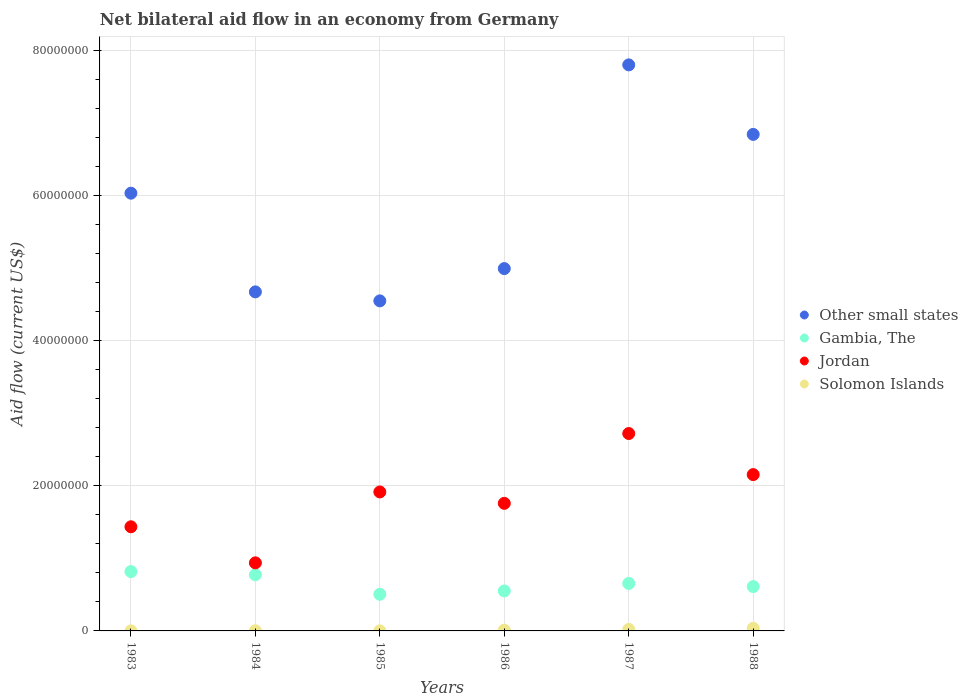How many different coloured dotlines are there?
Ensure brevity in your answer.  4. Is the number of dotlines equal to the number of legend labels?
Your answer should be compact. Yes. What is the net bilateral aid flow in Gambia, The in 1986?
Offer a terse response. 5.51e+06. Across all years, what is the maximum net bilateral aid flow in Jordan?
Give a very brief answer. 2.72e+07. In which year was the net bilateral aid flow in Other small states maximum?
Offer a very short reply. 1987. In which year was the net bilateral aid flow in Gambia, The minimum?
Provide a succinct answer. 1985. What is the total net bilateral aid flow in Solomon Islands in the graph?
Your answer should be compact. 7.20e+05. What is the difference between the net bilateral aid flow in Other small states in 1984 and that in 1988?
Keep it short and to the point. -2.17e+07. What is the difference between the net bilateral aid flow in Solomon Islands in 1985 and the net bilateral aid flow in Gambia, The in 1986?
Give a very brief answer. -5.50e+06. What is the average net bilateral aid flow in Jordan per year?
Give a very brief answer. 1.82e+07. In the year 1986, what is the difference between the net bilateral aid flow in Solomon Islands and net bilateral aid flow in Other small states?
Your answer should be very brief. -4.98e+07. In how many years, is the net bilateral aid flow in Gambia, The greater than 72000000 US$?
Offer a very short reply. 0. What is the ratio of the net bilateral aid flow in Gambia, The in 1985 to that in 1987?
Your answer should be very brief. 0.77. What is the difference between the highest and the lowest net bilateral aid flow in Solomon Islands?
Your response must be concise. 3.50e+05. Is it the case that in every year, the sum of the net bilateral aid flow in Jordan and net bilateral aid flow in Gambia, The  is greater than the net bilateral aid flow in Other small states?
Provide a short and direct response. No. Does the net bilateral aid flow in Other small states monotonically increase over the years?
Offer a terse response. No. Is the net bilateral aid flow in Gambia, The strictly greater than the net bilateral aid flow in Solomon Islands over the years?
Ensure brevity in your answer.  Yes. Is the net bilateral aid flow in Jordan strictly less than the net bilateral aid flow in Solomon Islands over the years?
Your answer should be very brief. No. Does the graph contain any zero values?
Your response must be concise. No. Where does the legend appear in the graph?
Your answer should be compact. Center right. What is the title of the graph?
Keep it short and to the point. Net bilateral aid flow in an economy from Germany. What is the label or title of the X-axis?
Keep it short and to the point. Years. What is the label or title of the Y-axis?
Provide a succinct answer. Aid flow (current US$). What is the Aid flow (current US$) of Other small states in 1983?
Offer a terse response. 6.03e+07. What is the Aid flow (current US$) in Gambia, The in 1983?
Offer a terse response. 8.18e+06. What is the Aid flow (current US$) in Jordan in 1983?
Provide a succinct answer. 1.44e+07. What is the Aid flow (current US$) of Other small states in 1984?
Ensure brevity in your answer.  4.67e+07. What is the Aid flow (current US$) in Gambia, The in 1984?
Ensure brevity in your answer.  7.74e+06. What is the Aid flow (current US$) of Jordan in 1984?
Your answer should be very brief. 9.38e+06. What is the Aid flow (current US$) in Other small states in 1985?
Ensure brevity in your answer.  4.55e+07. What is the Aid flow (current US$) in Gambia, The in 1985?
Your answer should be compact. 5.05e+06. What is the Aid flow (current US$) of Jordan in 1985?
Keep it short and to the point. 1.92e+07. What is the Aid flow (current US$) in Other small states in 1986?
Your answer should be compact. 4.99e+07. What is the Aid flow (current US$) in Gambia, The in 1986?
Provide a short and direct response. 5.51e+06. What is the Aid flow (current US$) in Jordan in 1986?
Ensure brevity in your answer.  1.76e+07. What is the Aid flow (current US$) in Solomon Islands in 1986?
Offer a very short reply. 1.10e+05. What is the Aid flow (current US$) in Other small states in 1987?
Provide a short and direct response. 7.80e+07. What is the Aid flow (current US$) of Gambia, The in 1987?
Give a very brief answer. 6.54e+06. What is the Aid flow (current US$) of Jordan in 1987?
Keep it short and to the point. 2.72e+07. What is the Aid flow (current US$) in Other small states in 1988?
Offer a very short reply. 6.84e+07. What is the Aid flow (current US$) in Gambia, The in 1988?
Keep it short and to the point. 6.11e+06. What is the Aid flow (current US$) in Jordan in 1988?
Ensure brevity in your answer.  2.15e+07. Across all years, what is the maximum Aid flow (current US$) in Other small states?
Your answer should be very brief. 7.80e+07. Across all years, what is the maximum Aid flow (current US$) of Gambia, The?
Provide a succinct answer. 8.18e+06. Across all years, what is the maximum Aid flow (current US$) in Jordan?
Provide a succinct answer. 2.72e+07. Across all years, what is the minimum Aid flow (current US$) in Other small states?
Give a very brief answer. 4.55e+07. Across all years, what is the minimum Aid flow (current US$) of Gambia, The?
Make the answer very short. 5.05e+06. Across all years, what is the minimum Aid flow (current US$) in Jordan?
Provide a short and direct response. 9.38e+06. What is the total Aid flow (current US$) in Other small states in the graph?
Your answer should be very brief. 3.49e+08. What is the total Aid flow (current US$) of Gambia, The in the graph?
Offer a very short reply. 3.91e+07. What is the total Aid flow (current US$) in Jordan in the graph?
Provide a short and direct response. 1.09e+08. What is the total Aid flow (current US$) in Solomon Islands in the graph?
Your response must be concise. 7.20e+05. What is the difference between the Aid flow (current US$) of Other small states in 1983 and that in 1984?
Offer a very short reply. 1.36e+07. What is the difference between the Aid flow (current US$) in Jordan in 1983 and that in 1984?
Your response must be concise. 4.97e+06. What is the difference between the Aid flow (current US$) of Other small states in 1983 and that in 1985?
Keep it short and to the point. 1.48e+07. What is the difference between the Aid flow (current US$) of Gambia, The in 1983 and that in 1985?
Ensure brevity in your answer.  3.13e+06. What is the difference between the Aid flow (current US$) of Jordan in 1983 and that in 1985?
Offer a very short reply. -4.80e+06. What is the difference between the Aid flow (current US$) of Solomon Islands in 1983 and that in 1985?
Ensure brevity in your answer.  0. What is the difference between the Aid flow (current US$) of Other small states in 1983 and that in 1986?
Keep it short and to the point. 1.04e+07. What is the difference between the Aid flow (current US$) in Gambia, The in 1983 and that in 1986?
Your answer should be very brief. 2.67e+06. What is the difference between the Aid flow (current US$) of Jordan in 1983 and that in 1986?
Give a very brief answer. -3.23e+06. What is the difference between the Aid flow (current US$) of Solomon Islands in 1983 and that in 1986?
Provide a succinct answer. -1.00e+05. What is the difference between the Aid flow (current US$) of Other small states in 1983 and that in 1987?
Your answer should be compact. -1.77e+07. What is the difference between the Aid flow (current US$) of Gambia, The in 1983 and that in 1987?
Give a very brief answer. 1.64e+06. What is the difference between the Aid flow (current US$) in Jordan in 1983 and that in 1987?
Ensure brevity in your answer.  -1.28e+07. What is the difference between the Aid flow (current US$) of Other small states in 1983 and that in 1988?
Your answer should be compact. -8.10e+06. What is the difference between the Aid flow (current US$) of Gambia, The in 1983 and that in 1988?
Your answer should be compact. 2.07e+06. What is the difference between the Aid flow (current US$) of Jordan in 1983 and that in 1988?
Your answer should be very brief. -7.19e+06. What is the difference between the Aid flow (current US$) of Solomon Islands in 1983 and that in 1988?
Make the answer very short. -3.50e+05. What is the difference between the Aid flow (current US$) of Other small states in 1984 and that in 1985?
Provide a succinct answer. 1.24e+06. What is the difference between the Aid flow (current US$) in Gambia, The in 1984 and that in 1985?
Your answer should be compact. 2.69e+06. What is the difference between the Aid flow (current US$) in Jordan in 1984 and that in 1985?
Provide a succinct answer. -9.77e+06. What is the difference between the Aid flow (current US$) of Other small states in 1984 and that in 1986?
Your answer should be very brief. -3.21e+06. What is the difference between the Aid flow (current US$) in Gambia, The in 1984 and that in 1986?
Give a very brief answer. 2.23e+06. What is the difference between the Aid flow (current US$) in Jordan in 1984 and that in 1986?
Make the answer very short. -8.20e+06. What is the difference between the Aid flow (current US$) of Solomon Islands in 1984 and that in 1986?
Provide a succinct answer. -9.00e+04. What is the difference between the Aid flow (current US$) in Other small states in 1984 and that in 1987?
Your response must be concise. -3.13e+07. What is the difference between the Aid flow (current US$) in Gambia, The in 1984 and that in 1987?
Make the answer very short. 1.20e+06. What is the difference between the Aid flow (current US$) of Jordan in 1984 and that in 1987?
Your response must be concise. -1.78e+07. What is the difference between the Aid flow (current US$) in Other small states in 1984 and that in 1988?
Offer a terse response. -2.17e+07. What is the difference between the Aid flow (current US$) in Gambia, The in 1984 and that in 1988?
Offer a very short reply. 1.63e+06. What is the difference between the Aid flow (current US$) in Jordan in 1984 and that in 1988?
Make the answer very short. -1.22e+07. What is the difference between the Aid flow (current US$) of Solomon Islands in 1984 and that in 1988?
Ensure brevity in your answer.  -3.40e+05. What is the difference between the Aid flow (current US$) of Other small states in 1985 and that in 1986?
Make the answer very short. -4.45e+06. What is the difference between the Aid flow (current US$) in Gambia, The in 1985 and that in 1986?
Give a very brief answer. -4.60e+05. What is the difference between the Aid flow (current US$) in Jordan in 1985 and that in 1986?
Provide a short and direct response. 1.57e+06. What is the difference between the Aid flow (current US$) of Solomon Islands in 1985 and that in 1986?
Provide a succinct answer. -1.00e+05. What is the difference between the Aid flow (current US$) in Other small states in 1985 and that in 1987?
Give a very brief answer. -3.25e+07. What is the difference between the Aid flow (current US$) of Gambia, The in 1985 and that in 1987?
Your answer should be very brief. -1.49e+06. What is the difference between the Aid flow (current US$) of Jordan in 1985 and that in 1987?
Your answer should be compact. -8.05e+06. What is the difference between the Aid flow (current US$) of Solomon Islands in 1985 and that in 1987?
Ensure brevity in your answer.  -2.00e+05. What is the difference between the Aid flow (current US$) of Other small states in 1985 and that in 1988?
Offer a terse response. -2.29e+07. What is the difference between the Aid flow (current US$) of Gambia, The in 1985 and that in 1988?
Offer a very short reply. -1.06e+06. What is the difference between the Aid flow (current US$) in Jordan in 1985 and that in 1988?
Your answer should be compact. -2.39e+06. What is the difference between the Aid flow (current US$) in Solomon Islands in 1985 and that in 1988?
Your answer should be very brief. -3.50e+05. What is the difference between the Aid flow (current US$) in Other small states in 1986 and that in 1987?
Your answer should be compact. -2.81e+07. What is the difference between the Aid flow (current US$) in Gambia, The in 1986 and that in 1987?
Ensure brevity in your answer.  -1.03e+06. What is the difference between the Aid flow (current US$) of Jordan in 1986 and that in 1987?
Make the answer very short. -9.62e+06. What is the difference between the Aid flow (current US$) of Solomon Islands in 1986 and that in 1987?
Make the answer very short. -1.00e+05. What is the difference between the Aid flow (current US$) in Other small states in 1986 and that in 1988?
Your answer should be compact. -1.85e+07. What is the difference between the Aid flow (current US$) in Gambia, The in 1986 and that in 1988?
Ensure brevity in your answer.  -6.00e+05. What is the difference between the Aid flow (current US$) of Jordan in 1986 and that in 1988?
Offer a terse response. -3.96e+06. What is the difference between the Aid flow (current US$) in Solomon Islands in 1986 and that in 1988?
Keep it short and to the point. -2.50e+05. What is the difference between the Aid flow (current US$) of Other small states in 1987 and that in 1988?
Ensure brevity in your answer.  9.58e+06. What is the difference between the Aid flow (current US$) in Jordan in 1987 and that in 1988?
Your answer should be very brief. 5.66e+06. What is the difference between the Aid flow (current US$) in Solomon Islands in 1987 and that in 1988?
Offer a very short reply. -1.50e+05. What is the difference between the Aid flow (current US$) of Other small states in 1983 and the Aid flow (current US$) of Gambia, The in 1984?
Keep it short and to the point. 5.26e+07. What is the difference between the Aid flow (current US$) of Other small states in 1983 and the Aid flow (current US$) of Jordan in 1984?
Provide a short and direct response. 5.09e+07. What is the difference between the Aid flow (current US$) in Other small states in 1983 and the Aid flow (current US$) in Solomon Islands in 1984?
Keep it short and to the point. 6.03e+07. What is the difference between the Aid flow (current US$) in Gambia, The in 1983 and the Aid flow (current US$) in Jordan in 1984?
Your answer should be compact. -1.20e+06. What is the difference between the Aid flow (current US$) of Gambia, The in 1983 and the Aid flow (current US$) of Solomon Islands in 1984?
Ensure brevity in your answer.  8.16e+06. What is the difference between the Aid flow (current US$) in Jordan in 1983 and the Aid flow (current US$) in Solomon Islands in 1984?
Make the answer very short. 1.43e+07. What is the difference between the Aid flow (current US$) of Other small states in 1983 and the Aid flow (current US$) of Gambia, The in 1985?
Your answer should be very brief. 5.53e+07. What is the difference between the Aid flow (current US$) in Other small states in 1983 and the Aid flow (current US$) in Jordan in 1985?
Your answer should be compact. 4.12e+07. What is the difference between the Aid flow (current US$) in Other small states in 1983 and the Aid flow (current US$) in Solomon Islands in 1985?
Offer a very short reply. 6.03e+07. What is the difference between the Aid flow (current US$) of Gambia, The in 1983 and the Aid flow (current US$) of Jordan in 1985?
Ensure brevity in your answer.  -1.10e+07. What is the difference between the Aid flow (current US$) in Gambia, The in 1983 and the Aid flow (current US$) in Solomon Islands in 1985?
Give a very brief answer. 8.17e+06. What is the difference between the Aid flow (current US$) of Jordan in 1983 and the Aid flow (current US$) of Solomon Islands in 1985?
Your answer should be compact. 1.43e+07. What is the difference between the Aid flow (current US$) of Other small states in 1983 and the Aid flow (current US$) of Gambia, The in 1986?
Ensure brevity in your answer.  5.48e+07. What is the difference between the Aid flow (current US$) in Other small states in 1983 and the Aid flow (current US$) in Jordan in 1986?
Offer a terse response. 4.27e+07. What is the difference between the Aid flow (current US$) in Other small states in 1983 and the Aid flow (current US$) in Solomon Islands in 1986?
Offer a terse response. 6.02e+07. What is the difference between the Aid flow (current US$) in Gambia, The in 1983 and the Aid flow (current US$) in Jordan in 1986?
Keep it short and to the point. -9.40e+06. What is the difference between the Aid flow (current US$) of Gambia, The in 1983 and the Aid flow (current US$) of Solomon Islands in 1986?
Give a very brief answer. 8.07e+06. What is the difference between the Aid flow (current US$) in Jordan in 1983 and the Aid flow (current US$) in Solomon Islands in 1986?
Keep it short and to the point. 1.42e+07. What is the difference between the Aid flow (current US$) of Other small states in 1983 and the Aid flow (current US$) of Gambia, The in 1987?
Offer a terse response. 5.38e+07. What is the difference between the Aid flow (current US$) of Other small states in 1983 and the Aid flow (current US$) of Jordan in 1987?
Offer a very short reply. 3.31e+07. What is the difference between the Aid flow (current US$) of Other small states in 1983 and the Aid flow (current US$) of Solomon Islands in 1987?
Your response must be concise. 6.01e+07. What is the difference between the Aid flow (current US$) of Gambia, The in 1983 and the Aid flow (current US$) of Jordan in 1987?
Ensure brevity in your answer.  -1.90e+07. What is the difference between the Aid flow (current US$) in Gambia, The in 1983 and the Aid flow (current US$) in Solomon Islands in 1987?
Give a very brief answer. 7.97e+06. What is the difference between the Aid flow (current US$) of Jordan in 1983 and the Aid flow (current US$) of Solomon Islands in 1987?
Offer a very short reply. 1.41e+07. What is the difference between the Aid flow (current US$) of Other small states in 1983 and the Aid flow (current US$) of Gambia, The in 1988?
Make the answer very short. 5.42e+07. What is the difference between the Aid flow (current US$) in Other small states in 1983 and the Aid flow (current US$) in Jordan in 1988?
Ensure brevity in your answer.  3.88e+07. What is the difference between the Aid flow (current US$) of Other small states in 1983 and the Aid flow (current US$) of Solomon Islands in 1988?
Offer a very short reply. 6.00e+07. What is the difference between the Aid flow (current US$) of Gambia, The in 1983 and the Aid flow (current US$) of Jordan in 1988?
Give a very brief answer. -1.34e+07. What is the difference between the Aid flow (current US$) of Gambia, The in 1983 and the Aid flow (current US$) of Solomon Islands in 1988?
Your answer should be very brief. 7.82e+06. What is the difference between the Aid flow (current US$) of Jordan in 1983 and the Aid flow (current US$) of Solomon Islands in 1988?
Provide a succinct answer. 1.40e+07. What is the difference between the Aid flow (current US$) in Other small states in 1984 and the Aid flow (current US$) in Gambia, The in 1985?
Offer a terse response. 4.17e+07. What is the difference between the Aid flow (current US$) in Other small states in 1984 and the Aid flow (current US$) in Jordan in 1985?
Give a very brief answer. 2.76e+07. What is the difference between the Aid flow (current US$) of Other small states in 1984 and the Aid flow (current US$) of Solomon Islands in 1985?
Offer a very short reply. 4.67e+07. What is the difference between the Aid flow (current US$) in Gambia, The in 1984 and the Aid flow (current US$) in Jordan in 1985?
Your answer should be compact. -1.14e+07. What is the difference between the Aid flow (current US$) of Gambia, The in 1984 and the Aid flow (current US$) of Solomon Islands in 1985?
Your answer should be very brief. 7.73e+06. What is the difference between the Aid flow (current US$) in Jordan in 1984 and the Aid flow (current US$) in Solomon Islands in 1985?
Offer a very short reply. 9.37e+06. What is the difference between the Aid flow (current US$) in Other small states in 1984 and the Aid flow (current US$) in Gambia, The in 1986?
Provide a succinct answer. 4.12e+07. What is the difference between the Aid flow (current US$) in Other small states in 1984 and the Aid flow (current US$) in Jordan in 1986?
Offer a terse response. 2.91e+07. What is the difference between the Aid flow (current US$) in Other small states in 1984 and the Aid flow (current US$) in Solomon Islands in 1986?
Offer a terse response. 4.66e+07. What is the difference between the Aid flow (current US$) in Gambia, The in 1984 and the Aid flow (current US$) in Jordan in 1986?
Make the answer very short. -9.84e+06. What is the difference between the Aid flow (current US$) of Gambia, The in 1984 and the Aid flow (current US$) of Solomon Islands in 1986?
Make the answer very short. 7.63e+06. What is the difference between the Aid flow (current US$) in Jordan in 1984 and the Aid flow (current US$) in Solomon Islands in 1986?
Your response must be concise. 9.27e+06. What is the difference between the Aid flow (current US$) of Other small states in 1984 and the Aid flow (current US$) of Gambia, The in 1987?
Provide a short and direct response. 4.02e+07. What is the difference between the Aid flow (current US$) in Other small states in 1984 and the Aid flow (current US$) in Jordan in 1987?
Offer a very short reply. 1.95e+07. What is the difference between the Aid flow (current US$) of Other small states in 1984 and the Aid flow (current US$) of Solomon Islands in 1987?
Offer a terse response. 4.65e+07. What is the difference between the Aid flow (current US$) in Gambia, The in 1984 and the Aid flow (current US$) in Jordan in 1987?
Your response must be concise. -1.95e+07. What is the difference between the Aid flow (current US$) of Gambia, The in 1984 and the Aid flow (current US$) of Solomon Islands in 1987?
Give a very brief answer. 7.53e+06. What is the difference between the Aid flow (current US$) in Jordan in 1984 and the Aid flow (current US$) in Solomon Islands in 1987?
Give a very brief answer. 9.17e+06. What is the difference between the Aid flow (current US$) of Other small states in 1984 and the Aid flow (current US$) of Gambia, The in 1988?
Your response must be concise. 4.06e+07. What is the difference between the Aid flow (current US$) in Other small states in 1984 and the Aid flow (current US$) in Jordan in 1988?
Provide a succinct answer. 2.52e+07. What is the difference between the Aid flow (current US$) of Other small states in 1984 and the Aid flow (current US$) of Solomon Islands in 1988?
Give a very brief answer. 4.64e+07. What is the difference between the Aid flow (current US$) in Gambia, The in 1984 and the Aid flow (current US$) in Jordan in 1988?
Provide a short and direct response. -1.38e+07. What is the difference between the Aid flow (current US$) of Gambia, The in 1984 and the Aid flow (current US$) of Solomon Islands in 1988?
Your response must be concise. 7.38e+06. What is the difference between the Aid flow (current US$) of Jordan in 1984 and the Aid flow (current US$) of Solomon Islands in 1988?
Offer a very short reply. 9.02e+06. What is the difference between the Aid flow (current US$) in Other small states in 1985 and the Aid flow (current US$) in Gambia, The in 1986?
Keep it short and to the point. 4.00e+07. What is the difference between the Aid flow (current US$) in Other small states in 1985 and the Aid flow (current US$) in Jordan in 1986?
Your answer should be very brief. 2.79e+07. What is the difference between the Aid flow (current US$) in Other small states in 1985 and the Aid flow (current US$) in Solomon Islands in 1986?
Give a very brief answer. 4.54e+07. What is the difference between the Aid flow (current US$) of Gambia, The in 1985 and the Aid flow (current US$) of Jordan in 1986?
Offer a very short reply. -1.25e+07. What is the difference between the Aid flow (current US$) of Gambia, The in 1985 and the Aid flow (current US$) of Solomon Islands in 1986?
Offer a terse response. 4.94e+06. What is the difference between the Aid flow (current US$) in Jordan in 1985 and the Aid flow (current US$) in Solomon Islands in 1986?
Your response must be concise. 1.90e+07. What is the difference between the Aid flow (current US$) of Other small states in 1985 and the Aid flow (current US$) of Gambia, The in 1987?
Ensure brevity in your answer.  3.89e+07. What is the difference between the Aid flow (current US$) in Other small states in 1985 and the Aid flow (current US$) in Jordan in 1987?
Ensure brevity in your answer.  1.83e+07. What is the difference between the Aid flow (current US$) of Other small states in 1985 and the Aid flow (current US$) of Solomon Islands in 1987?
Ensure brevity in your answer.  4.53e+07. What is the difference between the Aid flow (current US$) of Gambia, The in 1985 and the Aid flow (current US$) of Jordan in 1987?
Ensure brevity in your answer.  -2.22e+07. What is the difference between the Aid flow (current US$) of Gambia, The in 1985 and the Aid flow (current US$) of Solomon Islands in 1987?
Offer a terse response. 4.84e+06. What is the difference between the Aid flow (current US$) in Jordan in 1985 and the Aid flow (current US$) in Solomon Islands in 1987?
Offer a very short reply. 1.89e+07. What is the difference between the Aid flow (current US$) in Other small states in 1985 and the Aid flow (current US$) in Gambia, The in 1988?
Your response must be concise. 3.94e+07. What is the difference between the Aid flow (current US$) of Other small states in 1985 and the Aid flow (current US$) of Jordan in 1988?
Your response must be concise. 2.39e+07. What is the difference between the Aid flow (current US$) in Other small states in 1985 and the Aid flow (current US$) in Solomon Islands in 1988?
Ensure brevity in your answer.  4.51e+07. What is the difference between the Aid flow (current US$) in Gambia, The in 1985 and the Aid flow (current US$) in Jordan in 1988?
Offer a terse response. -1.65e+07. What is the difference between the Aid flow (current US$) of Gambia, The in 1985 and the Aid flow (current US$) of Solomon Islands in 1988?
Your answer should be very brief. 4.69e+06. What is the difference between the Aid flow (current US$) in Jordan in 1985 and the Aid flow (current US$) in Solomon Islands in 1988?
Ensure brevity in your answer.  1.88e+07. What is the difference between the Aid flow (current US$) in Other small states in 1986 and the Aid flow (current US$) in Gambia, The in 1987?
Provide a short and direct response. 4.34e+07. What is the difference between the Aid flow (current US$) in Other small states in 1986 and the Aid flow (current US$) in Jordan in 1987?
Provide a short and direct response. 2.27e+07. What is the difference between the Aid flow (current US$) in Other small states in 1986 and the Aid flow (current US$) in Solomon Islands in 1987?
Give a very brief answer. 4.97e+07. What is the difference between the Aid flow (current US$) in Gambia, The in 1986 and the Aid flow (current US$) in Jordan in 1987?
Your response must be concise. -2.17e+07. What is the difference between the Aid flow (current US$) of Gambia, The in 1986 and the Aid flow (current US$) of Solomon Islands in 1987?
Make the answer very short. 5.30e+06. What is the difference between the Aid flow (current US$) in Jordan in 1986 and the Aid flow (current US$) in Solomon Islands in 1987?
Your response must be concise. 1.74e+07. What is the difference between the Aid flow (current US$) of Other small states in 1986 and the Aid flow (current US$) of Gambia, The in 1988?
Make the answer very short. 4.38e+07. What is the difference between the Aid flow (current US$) of Other small states in 1986 and the Aid flow (current US$) of Jordan in 1988?
Give a very brief answer. 2.84e+07. What is the difference between the Aid flow (current US$) of Other small states in 1986 and the Aid flow (current US$) of Solomon Islands in 1988?
Provide a short and direct response. 4.96e+07. What is the difference between the Aid flow (current US$) of Gambia, The in 1986 and the Aid flow (current US$) of Jordan in 1988?
Your response must be concise. -1.60e+07. What is the difference between the Aid flow (current US$) of Gambia, The in 1986 and the Aid flow (current US$) of Solomon Islands in 1988?
Your answer should be compact. 5.15e+06. What is the difference between the Aid flow (current US$) of Jordan in 1986 and the Aid flow (current US$) of Solomon Islands in 1988?
Offer a terse response. 1.72e+07. What is the difference between the Aid flow (current US$) of Other small states in 1987 and the Aid flow (current US$) of Gambia, The in 1988?
Offer a very short reply. 7.19e+07. What is the difference between the Aid flow (current US$) of Other small states in 1987 and the Aid flow (current US$) of Jordan in 1988?
Your answer should be compact. 5.65e+07. What is the difference between the Aid flow (current US$) of Other small states in 1987 and the Aid flow (current US$) of Solomon Islands in 1988?
Your answer should be compact. 7.76e+07. What is the difference between the Aid flow (current US$) in Gambia, The in 1987 and the Aid flow (current US$) in Jordan in 1988?
Your response must be concise. -1.50e+07. What is the difference between the Aid flow (current US$) of Gambia, The in 1987 and the Aid flow (current US$) of Solomon Islands in 1988?
Offer a very short reply. 6.18e+06. What is the difference between the Aid flow (current US$) of Jordan in 1987 and the Aid flow (current US$) of Solomon Islands in 1988?
Provide a succinct answer. 2.68e+07. What is the average Aid flow (current US$) of Other small states per year?
Ensure brevity in your answer.  5.81e+07. What is the average Aid flow (current US$) of Gambia, The per year?
Ensure brevity in your answer.  6.52e+06. What is the average Aid flow (current US$) of Jordan per year?
Provide a short and direct response. 1.82e+07. What is the average Aid flow (current US$) in Solomon Islands per year?
Give a very brief answer. 1.20e+05. In the year 1983, what is the difference between the Aid flow (current US$) of Other small states and Aid flow (current US$) of Gambia, The?
Offer a very short reply. 5.21e+07. In the year 1983, what is the difference between the Aid flow (current US$) of Other small states and Aid flow (current US$) of Jordan?
Offer a very short reply. 4.60e+07. In the year 1983, what is the difference between the Aid flow (current US$) of Other small states and Aid flow (current US$) of Solomon Islands?
Keep it short and to the point. 6.03e+07. In the year 1983, what is the difference between the Aid flow (current US$) of Gambia, The and Aid flow (current US$) of Jordan?
Give a very brief answer. -6.17e+06. In the year 1983, what is the difference between the Aid flow (current US$) of Gambia, The and Aid flow (current US$) of Solomon Islands?
Provide a short and direct response. 8.17e+06. In the year 1983, what is the difference between the Aid flow (current US$) in Jordan and Aid flow (current US$) in Solomon Islands?
Provide a short and direct response. 1.43e+07. In the year 1984, what is the difference between the Aid flow (current US$) in Other small states and Aid flow (current US$) in Gambia, The?
Keep it short and to the point. 3.90e+07. In the year 1984, what is the difference between the Aid flow (current US$) of Other small states and Aid flow (current US$) of Jordan?
Your response must be concise. 3.73e+07. In the year 1984, what is the difference between the Aid flow (current US$) of Other small states and Aid flow (current US$) of Solomon Islands?
Ensure brevity in your answer.  4.67e+07. In the year 1984, what is the difference between the Aid flow (current US$) of Gambia, The and Aid flow (current US$) of Jordan?
Keep it short and to the point. -1.64e+06. In the year 1984, what is the difference between the Aid flow (current US$) of Gambia, The and Aid flow (current US$) of Solomon Islands?
Your answer should be compact. 7.72e+06. In the year 1984, what is the difference between the Aid flow (current US$) in Jordan and Aid flow (current US$) in Solomon Islands?
Make the answer very short. 9.36e+06. In the year 1985, what is the difference between the Aid flow (current US$) in Other small states and Aid flow (current US$) in Gambia, The?
Keep it short and to the point. 4.04e+07. In the year 1985, what is the difference between the Aid flow (current US$) in Other small states and Aid flow (current US$) in Jordan?
Give a very brief answer. 2.63e+07. In the year 1985, what is the difference between the Aid flow (current US$) of Other small states and Aid flow (current US$) of Solomon Islands?
Keep it short and to the point. 4.55e+07. In the year 1985, what is the difference between the Aid flow (current US$) in Gambia, The and Aid flow (current US$) in Jordan?
Give a very brief answer. -1.41e+07. In the year 1985, what is the difference between the Aid flow (current US$) of Gambia, The and Aid flow (current US$) of Solomon Islands?
Ensure brevity in your answer.  5.04e+06. In the year 1985, what is the difference between the Aid flow (current US$) in Jordan and Aid flow (current US$) in Solomon Islands?
Provide a succinct answer. 1.91e+07. In the year 1986, what is the difference between the Aid flow (current US$) of Other small states and Aid flow (current US$) of Gambia, The?
Provide a succinct answer. 4.44e+07. In the year 1986, what is the difference between the Aid flow (current US$) in Other small states and Aid flow (current US$) in Jordan?
Offer a very short reply. 3.24e+07. In the year 1986, what is the difference between the Aid flow (current US$) of Other small states and Aid flow (current US$) of Solomon Islands?
Your answer should be very brief. 4.98e+07. In the year 1986, what is the difference between the Aid flow (current US$) in Gambia, The and Aid flow (current US$) in Jordan?
Your answer should be very brief. -1.21e+07. In the year 1986, what is the difference between the Aid flow (current US$) of Gambia, The and Aid flow (current US$) of Solomon Islands?
Your answer should be compact. 5.40e+06. In the year 1986, what is the difference between the Aid flow (current US$) of Jordan and Aid flow (current US$) of Solomon Islands?
Give a very brief answer. 1.75e+07. In the year 1987, what is the difference between the Aid flow (current US$) of Other small states and Aid flow (current US$) of Gambia, The?
Your answer should be compact. 7.15e+07. In the year 1987, what is the difference between the Aid flow (current US$) in Other small states and Aid flow (current US$) in Jordan?
Offer a very short reply. 5.08e+07. In the year 1987, what is the difference between the Aid flow (current US$) of Other small states and Aid flow (current US$) of Solomon Islands?
Offer a very short reply. 7.78e+07. In the year 1987, what is the difference between the Aid flow (current US$) in Gambia, The and Aid flow (current US$) in Jordan?
Your answer should be compact. -2.07e+07. In the year 1987, what is the difference between the Aid flow (current US$) of Gambia, The and Aid flow (current US$) of Solomon Islands?
Make the answer very short. 6.33e+06. In the year 1987, what is the difference between the Aid flow (current US$) in Jordan and Aid flow (current US$) in Solomon Islands?
Keep it short and to the point. 2.70e+07. In the year 1988, what is the difference between the Aid flow (current US$) in Other small states and Aid flow (current US$) in Gambia, The?
Your answer should be compact. 6.23e+07. In the year 1988, what is the difference between the Aid flow (current US$) in Other small states and Aid flow (current US$) in Jordan?
Offer a very short reply. 4.69e+07. In the year 1988, what is the difference between the Aid flow (current US$) in Other small states and Aid flow (current US$) in Solomon Islands?
Your answer should be compact. 6.81e+07. In the year 1988, what is the difference between the Aid flow (current US$) in Gambia, The and Aid flow (current US$) in Jordan?
Give a very brief answer. -1.54e+07. In the year 1988, what is the difference between the Aid flow (current US$) of Gambia, The and Aid flow (current US$) of Solomon Islands?
Your answer should be very brief. 5.75e+06. In the year 1988, what is the difference between the Aid flow (current US$) in Jordan and Aid flow (current US$) in Solomon Islands?
Offer a very short reply. 2.12e+07. What is the ratio of the Aid flow (current US$) in Other small states in 1983 to that in 1984?
Provide a succinct answer. 1.29. What is the ratio of the Aid flow (current US$) of Gambia, The in 1983 to that in 1984?
Make the answer very short. 1.06. What is the ratio of the Aid flow (current US$) in Jordan in 1983 to that in 1984?
Provide a short and direct response. 1.53. What is the ratio of the Aid flow (current US$) of Other small states in 1983 to that in 1985?
Give a very brief answer. 1.33. What is the ratio of the Aid flow (current US$) of Gambia, The in 1983 to that in 1985?
Give a very brief answer. 1.62. What is the ratio of the Aid flow (current US$) of Jordan in 1983 to that in 1985?
Give a very brief answer. 0.75. What is the ratio of the Aid flow (current US$) of Other small states in 1983 to that in 1986?
Provide a short and direct response. 1.21. What is the ratio of the Aid flow (current US$) in Gambia, The in 1983 to that in 1986?
Ensure brevity in your answer.  1.48. What is the ratio of the Aid flow (current US$) of Jordan in 1983 to that in 1986?
Provide a succinct answer. 0.82. What is the ratio of the Aid flow (current US$) in Solomon Islands in 1983 to that in 1986?
Keep it short and to the point. 0.09. What is the ratio of the Aid flow (current US$) of Other small states in 1983 to that in 1987?
Provide a succinct answer. 0.77. What is the ratio of the Aid flow (current US$) in Gambia, The in 1983 to that in 1987?
Your answer should be compact. 1.25. What is the ratio of the Aid flow (current US$) in Jordan in 1983 to that in 1987?
Your answer should be compact. 0.53. What is the ratio of the Aid flow (current US$) of Solomon Islands in 1983 to that in 1987?
Make the answer very short. 0.05. What is the ratio of the Aid flow (current US$) of Other small states in 1983 to that in 1988?
Ensure brevity in your answer.  0.88. What is the ratio of the Aid flow (current US$) in Gambia, The in 1983 to that in 1988?
Make the answer very short. 1.34. What is the ratio of the Aid flow (current US$) in Jordan in 1983 to that in 1988?
Keep it short and to the point. 0.67. What is the ratio of the Aid flow (current US$) of Solomon Islands in 1983 to that in 1988?
Your answer should be compact. 0.03. What is the ratio of the Aid flow (current US$) in Other small states in 1984 to that in 1985?
Your response must be concise. 1.03. What is the ratio of the Aid flow (current US$) of Gambia, The in 1984 to that in 1985?
Your answer should be very brief. 1.53. What is the ratio of the Aid flow (current US$) in Jordan in 1984 to that in 1985?
Make the answer very short. 0.49. What is the ratio of the Aid flow (current US$) of Solomon Islands in 1984 to that in 1985?
Offer a very short reply. 2. What is the ratio of the Aid flow (current US$) in Other small states in 1984 to that in 1986?
Make the answer very short. 0.94. What is the ratio of the Aid flow (current US$) in Gambia, The in 1984 to that in 1986?
Offer a very short reply. 1.4. What is the ratio of the Aid flow (current US$) in Jordan in 1984 to that in 1986?
Give a very brief answer. 0.53. What is the ratio of the Aid flow (current US$) in Solomon Islands in 1984 to that in 1986?
Keep it short and to the point. 0.18. What is the ratio of the Aid flow (current US$) of Other small states in 1984 to that in 1987?
Offer a very short reply. 0.6. What is the ratio of the Aid flow (current US$) in Gambia, The in 1984 to that in 1987?
Provide a short and direct response. 1.18. What is the ratio of the Aid flow (current US$) in Jordan in 1984 to that in 1987?
Your answer should be compact. 0.34. What is the ratio of the Aid flow (current US$) in Solomon Islands in 1984 to that in 1987?
Your answer should be very brief. 0.1. What is the ratio of the Aid flow (current US$) of Other small states in 1984 to that in 1988?
Provide a succinct answer. 0.68. What is the ratio of the Aid flow (current US$) in Gambia, The in 1984 to that in 1988?
Your response must be concise. 1.27. What is the ratio of the Aid flow (current US$) in Jordan in 1984 to that in 1988?
Give a very brief answer. 0.44. What is the ratio of the Aid flow (current US$) of Solomon Islands in 1984 to that in 1988?
Give a very brief answer. 0.06. What is the ratio of the Aid flow (current US$) in Other small states in 1985 to that in 1986?
Provide a short and direct response. 0.91. What is the ratio of the Aid flow (current US$) in Gambia, The in 1985 to that in 1986?
Keep it short and to the point. 0.92. What is the ratio of the Aid flow (current US$) of Jordan in 1985 to that in 1986?
Provide a succinct answer. 1.09. What is the ratio of the Aid flow (current US$) of Solomon Islands in 1985 to that in 1986?
Your response must be concise. 0.09. What is the ratio of the Aid flow (current US$) in Other small states in 1985 to that in 1987?
Your answer should be very brief. 0.58. What is the ratio of the Aid flow (current US$) in Gambia, The in 1985 to that in 1987?
Offer a very short reply. 0.77. What is the ratio of the Aid flow (current US$) of Jordan in 1985 to that in 1987?
Your answer should be compact. 0.7. What is the ratio of the Aid flow (current US$) of Solomon Islands in 1985 to that in 1987?
Ensure brevity in your answer.  0.05. What is the ratio of the Aid flow (current US$) of Other small states in 1985 to that in 1988?
Your answer should be very brief. 0.66. What is the ratio of the Aid flow (current US$) of Gambia, The in 1985 to that in 1988?
Your answer should be compact. 0.83. What is the ratio of the Aid flow (current US$) in Jordan in 1985 to that in 1988?
Provide a succinct answer. 0.89. What is the ratio of the Aid flow (current US$) of Solomon Islands in 1985 to that in 1988?
Your answer should be very brief. 0.03. What is the ratio of the Aid flow (current US$) in Other small states in 1986 to that in 1987?
Your answer should be very brief. 0.64. What is the ratio of the Aid flow (current US$) in Gambia, The in 1986 to that in 1987?
Your answer should be compact. 0.84. What is the ratio of the Aid flow (current US$) of Jordan in 1986 to that in 1987?
Ensure brevity in your answer.  0.65. What is the ratio of the Aid flow (current US$) of Solomon Islands in 1986 to that in 1987?
Provide a succinct answer. 0.52. What is the ratio of the Aid flow (current US$) in Other small states in 1986 to that in 1988?
Your response must be concise. 0.73. What is the ratio of the Aid flow (current US$) of Gambia, The in 1986 to that in 1988?
Make the answer very short. 0.9. What is the ratio of the Aid flow (current US$) in Jordan in 1986 to that in 1988?
Your answer should be compact. 0.82. What is the ratio of the Aid flow (current US$) of Solomon Islands in 1986 to that in 1988?
Ensure brevity in your answer.  0.31. What is the ratio of the Aid flow (current US$) of Other small states in 1987 to that in 1988?
Provide a short and direct response. 1.14. What is the ratio of the Aid flow (current US$) of Gambia, The in 1987 to that in 1988?
Provide a succinct answer. 1.07. What is the ratio of the Aid flow (current US$) of Jordan in 1987 to that in 1988?
Your answer should be compact. 1.26. What is the ratio of the Aid flow (current US$) of Solomon Islands in 1987 to that in 1988?
Ensure brevity in your answer.  0.58. What is the difference between the highest and the second highest Aid flow (current US$) in Other small states?
Provide a short and direct response. 9.58e+06. What is the difference between the highest and the second highest Aid flow (current US$) of Jordan?
Offer a terse response. 5.66e+06. What is the difference between the highest and the lowest Aid flow (current US$) in Other small states?
Ensure brevity in your answer.  3.25e+07. What is the difference between the highest and the lowest Aid flow (current US$) in Gambia, The?
Keep it short and to the point. 3.13e+06. What is the difference between the highest and the lowest Aid flow (current US$) in Jordan?
Keep it short and to the point. 1.78e+07. 